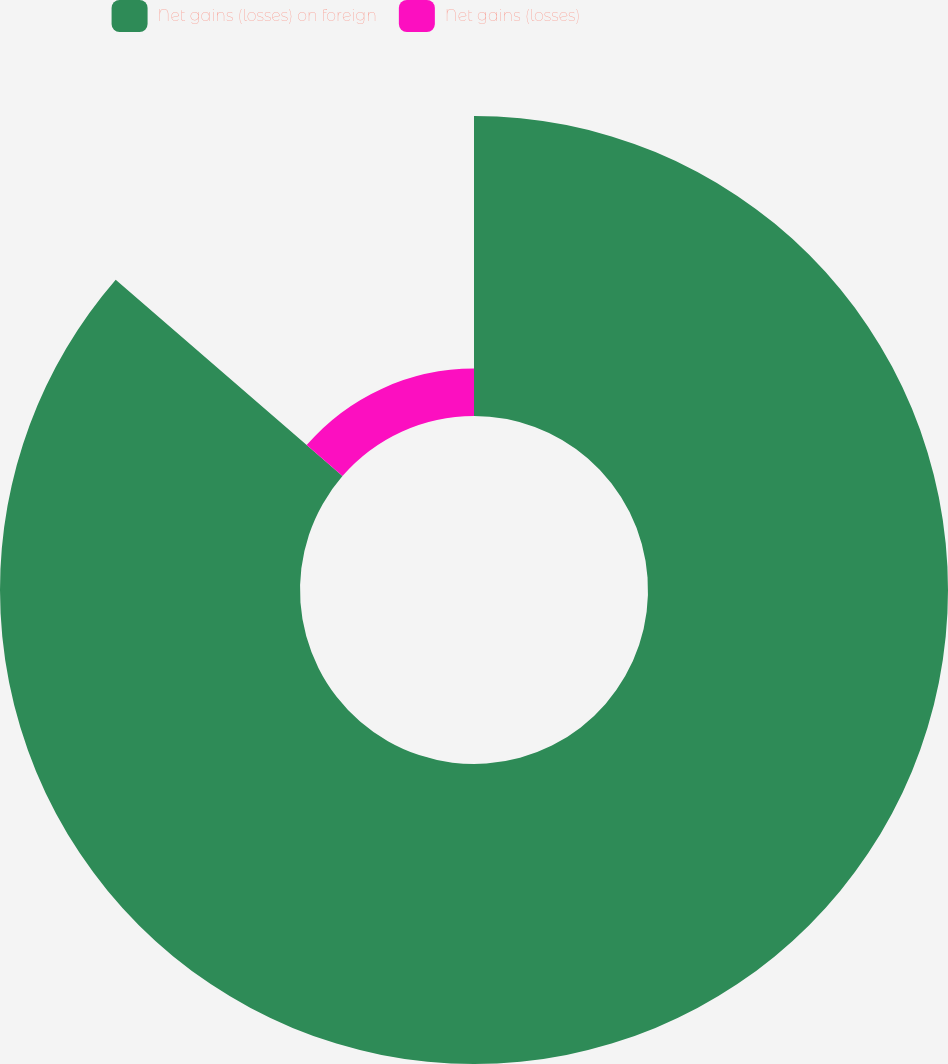<chart> <loc_0><loc_0><loc_500><loc_500><pie_chart><fcel>Net gains (losses) on foreign<fcel>Net gains (losses)<nl><fcel>86.36%<fcel>13.64%<nl></chart> 